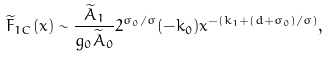<formula> <loc_0><loc_0><loc_500><loc_500>\widetilde { F } _ { 1 C } ( x ) \sim \frac { \widetilde { A } _ { 1 } } { g _ { 0 } \widetilde { A } _ { 0 } } 2 ^ { \sigma _ { 0 } / \sigma } ( - k _ { 0 } ) x ^ { - ( k _ { 1 } + ( d + \sigma _ { 0 } ) / \sigma ) } ,</formula> 